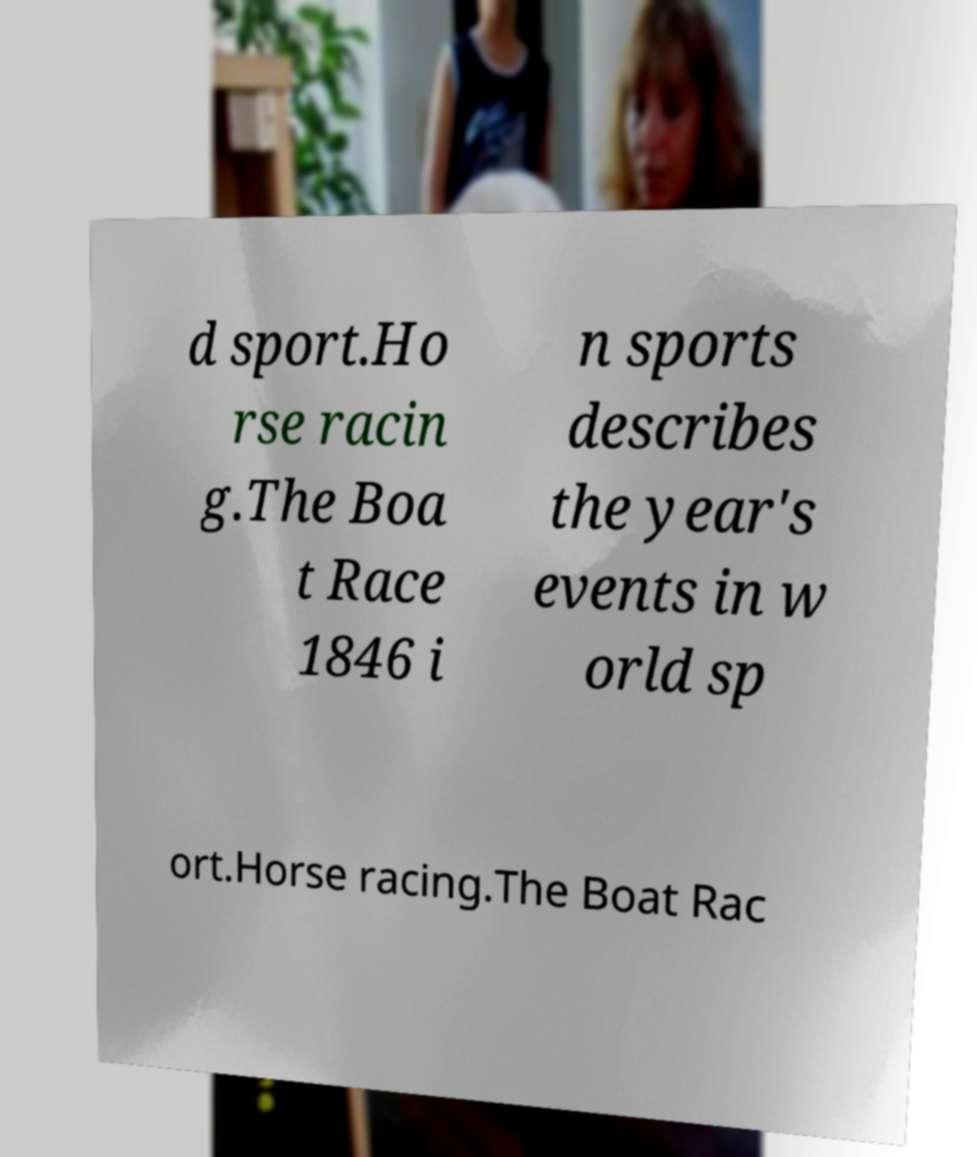What messages or text are displayed in this image? I need them in a readable, typed format. d sport.Ho rse racin g.The Boa t Race 1846 i n sports describes the year's events in w orld sp ort.Horse racing.The Boat Rac 